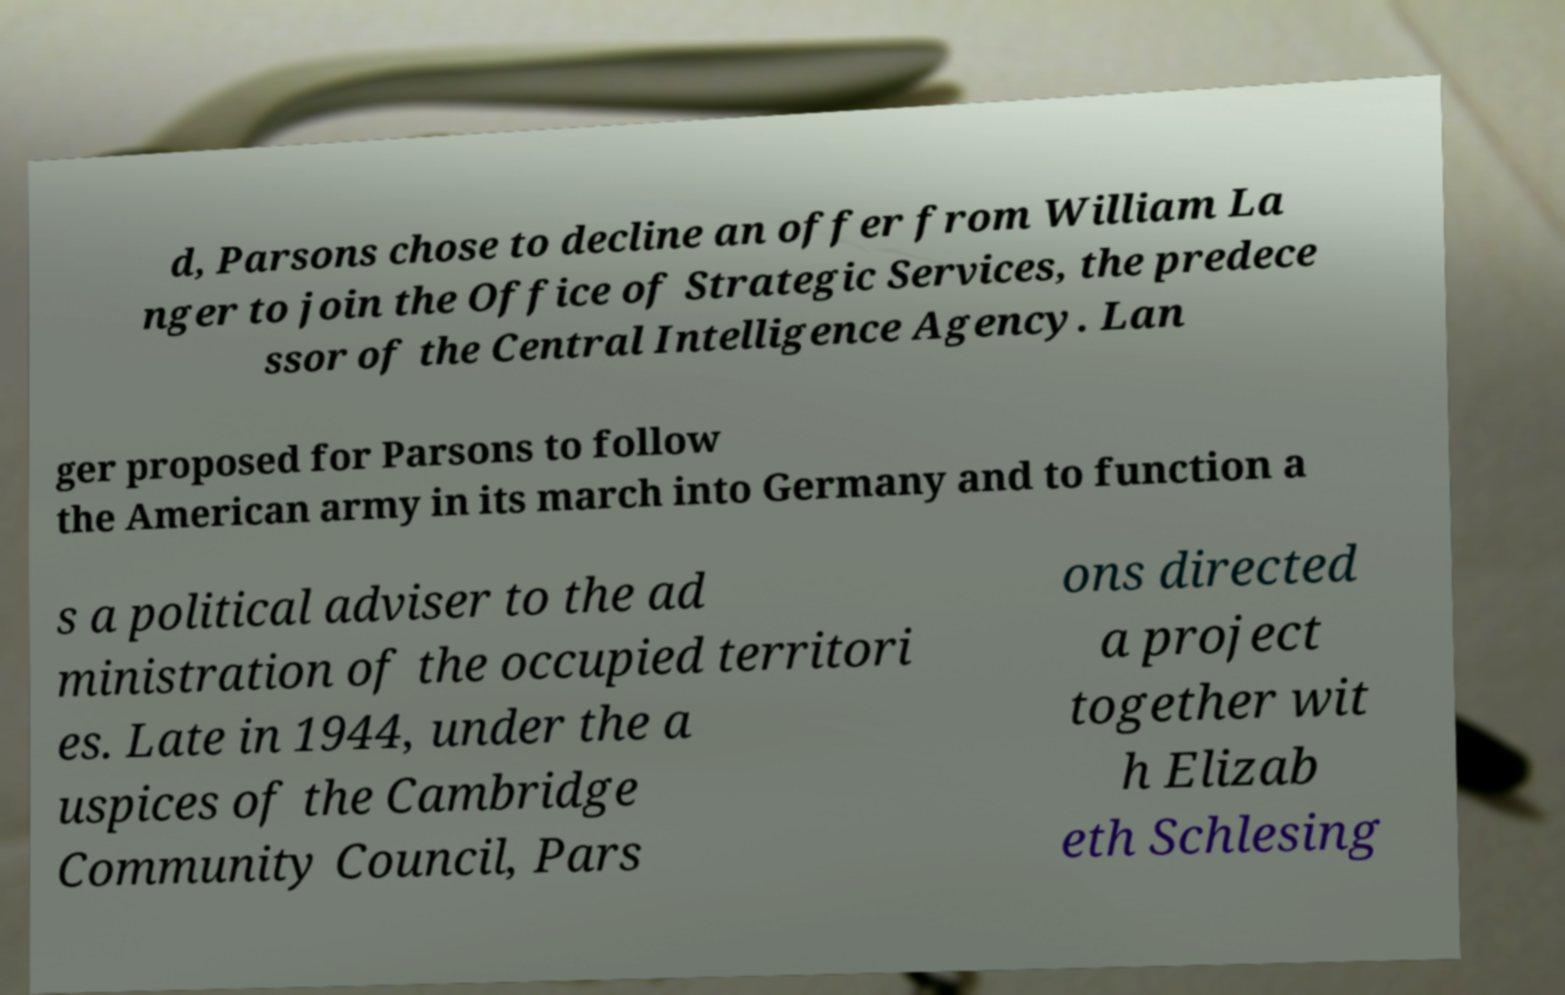Can you accurately transcribe the text from the provided image for me? d, Parsons chose to decline an offer from William La nger to join the Office of Strategic Services, the predece ssor of the Central Intelligence Agency. Lan ger proposed for Parsons to follow the American army in its march into Germany and to function a s a political adviser to the ad ministration of the occupied territori es. Late in 1944, under the a uspices of the Cambridge Community Council, Pars ons directed a project together wit h Elizab eth Schlesing 